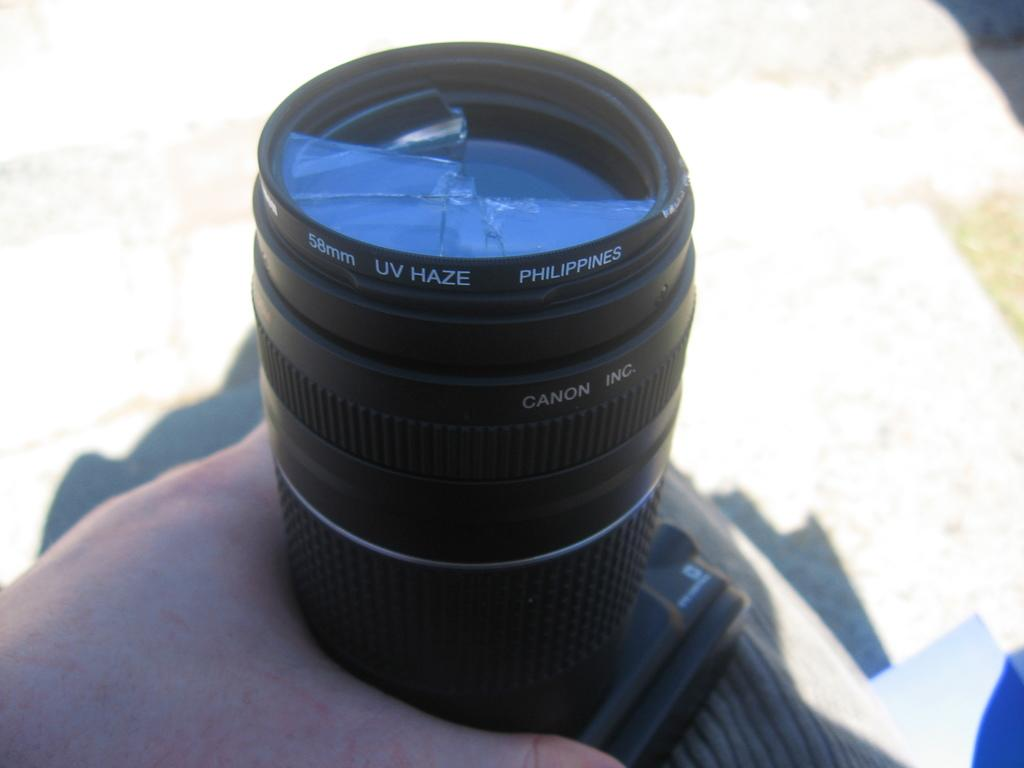What part of a person can be seen in the image? There is a person's hand in the image. What is the person holding in the image? The person is holding a camera. What is the condition of the camera in the image? The camera lens is broken. What can be seen in the background of the image? There is a shadow on a pathway behind the camera. What type of cave can be seen in the image? There is no cave present in the image. What scientific experiment is being conducted in the image? There is no scientific experiment being conducted in the image. 